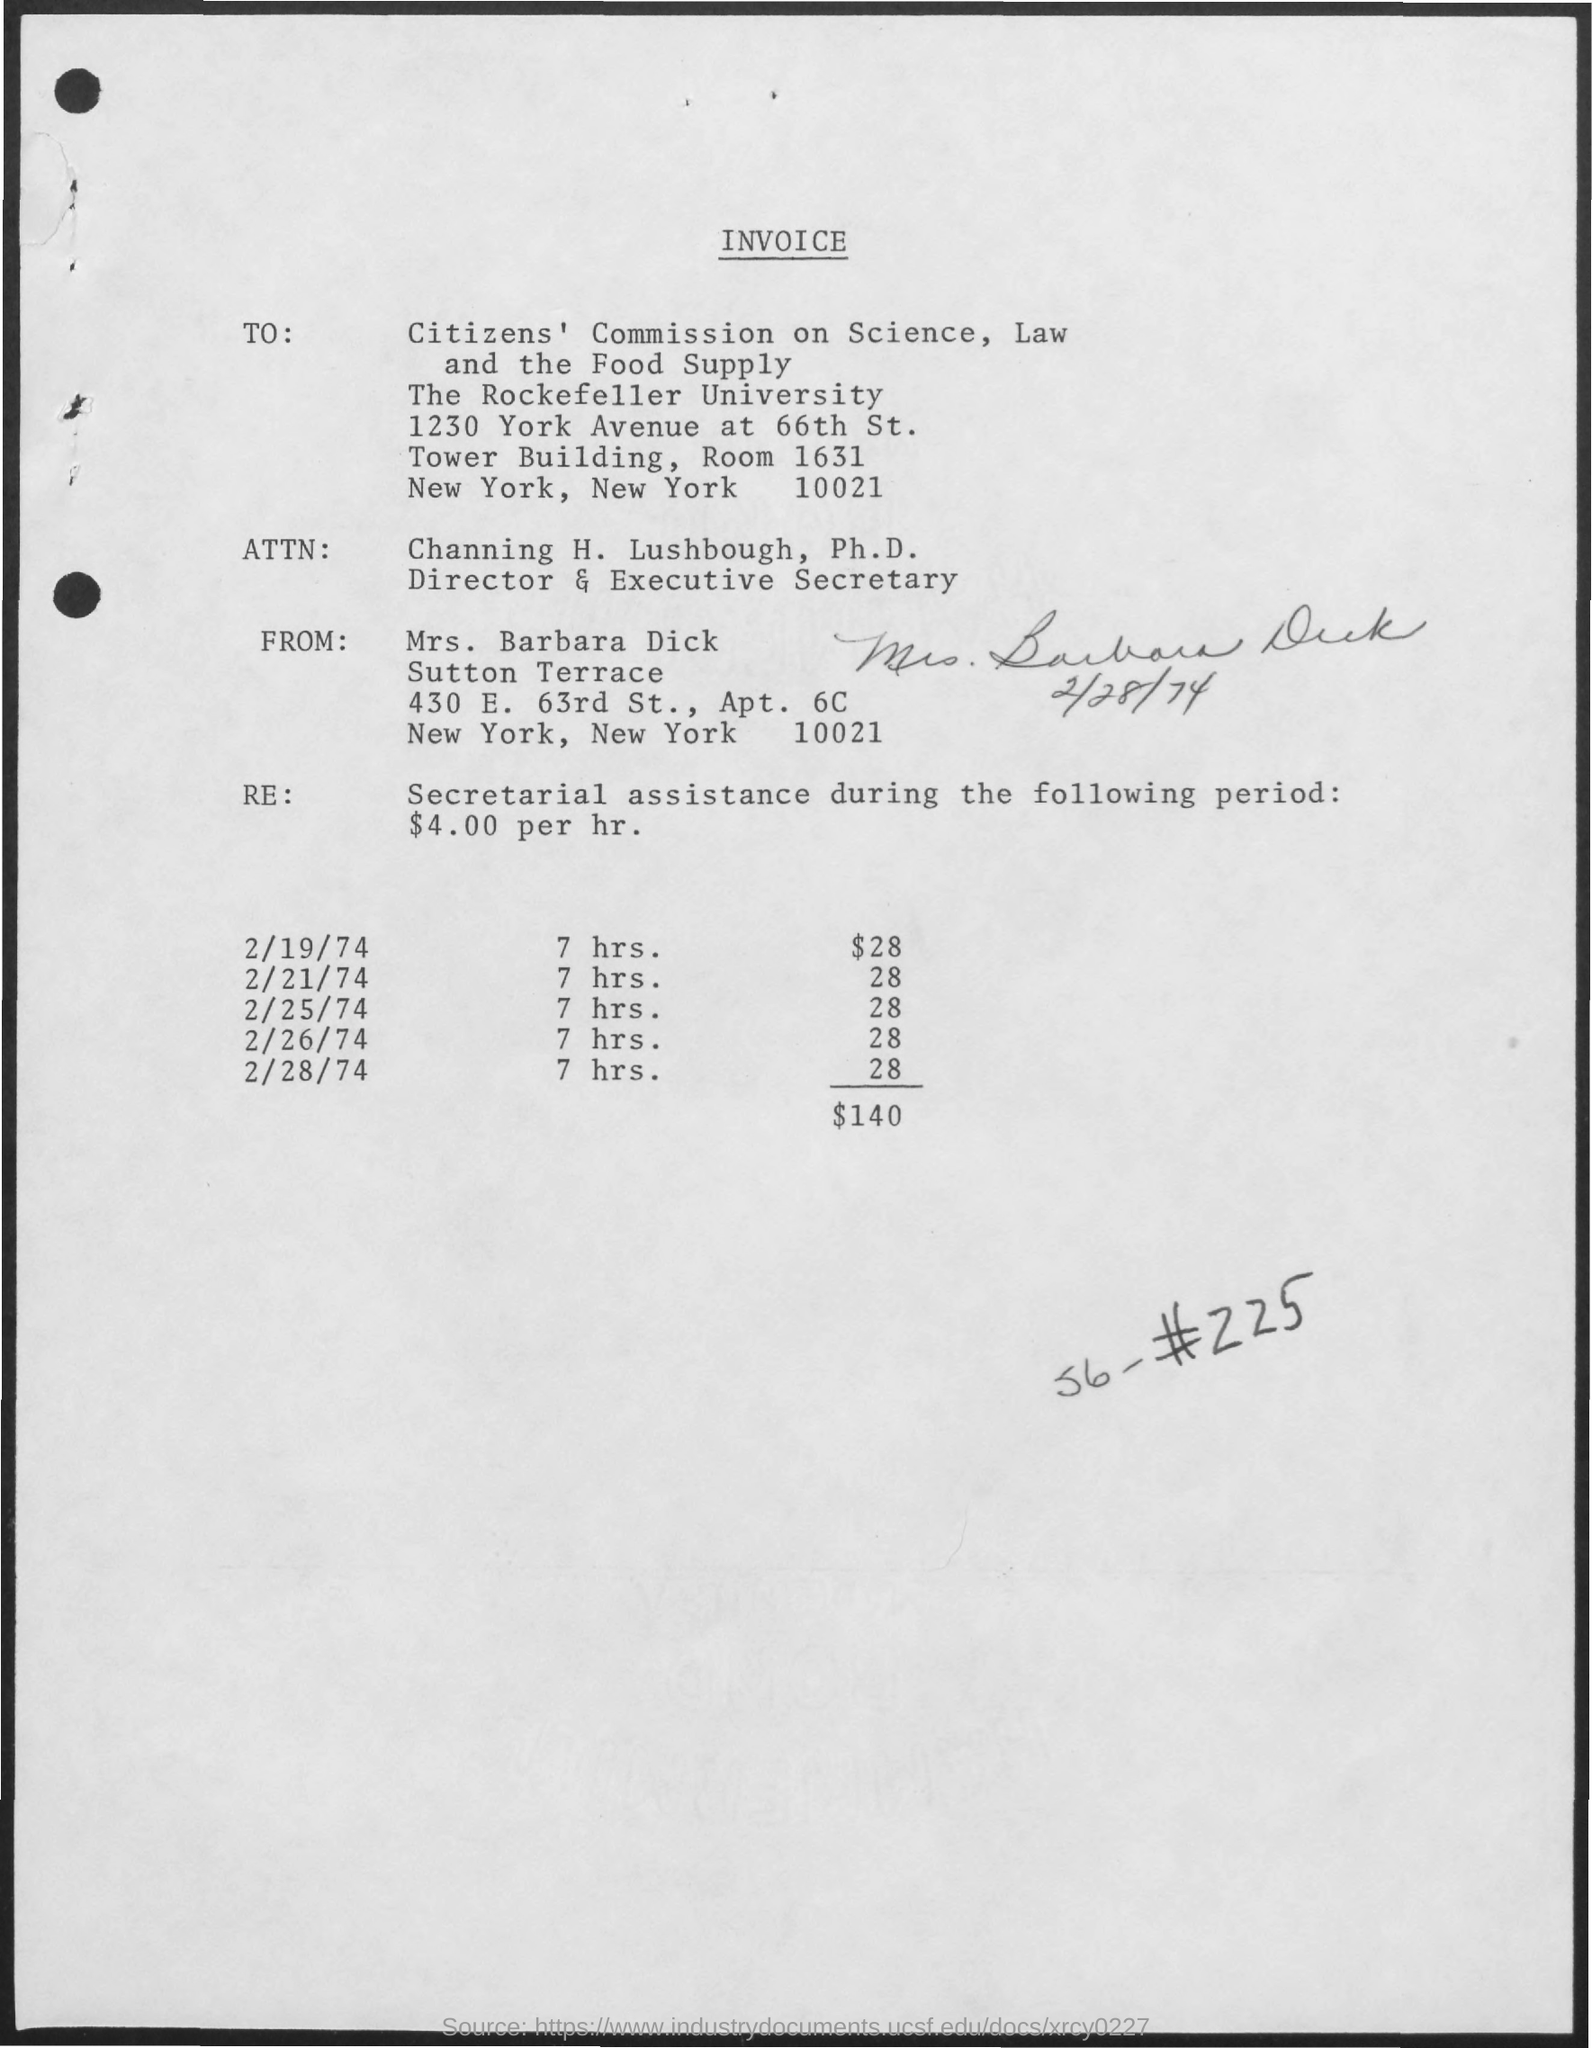From whom the invoice is delivered ?
Give a very brief answer. MRS. BARBARA DICK. What is the designation of channing h. lushbough ?
Make the answer very short. DIRECTOR& EXECUTIVE SECRETARY. What is the amount given for 7 hrs. on 2/19/74 ?
Make the answer very short. $28. 